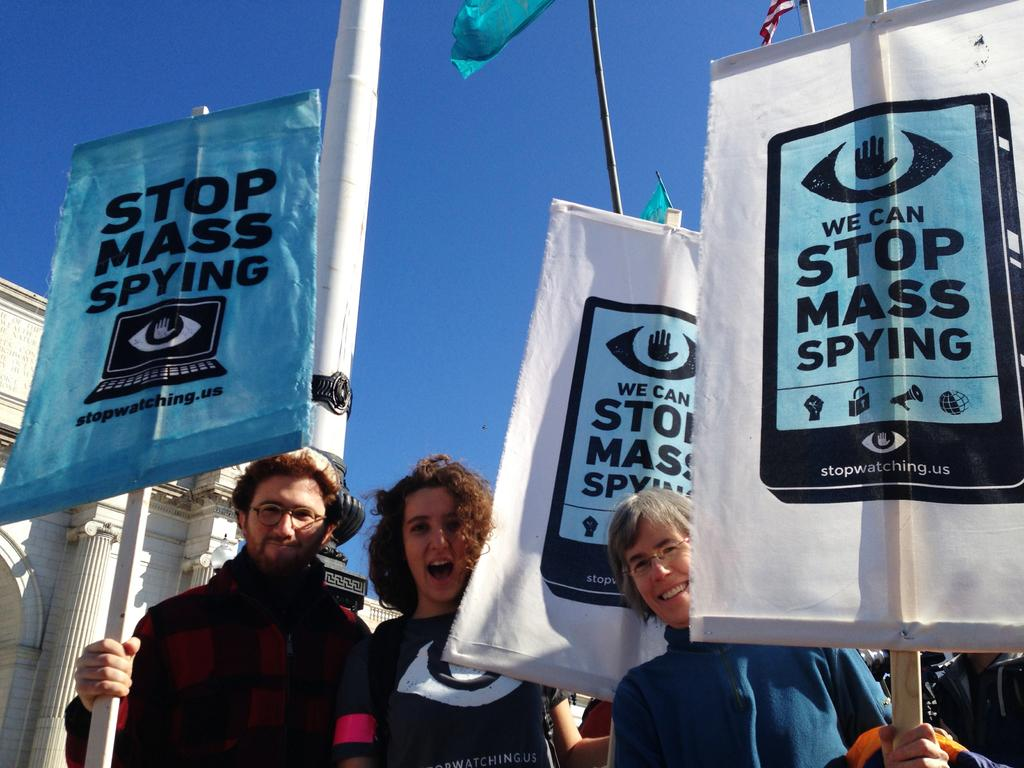What are the people in the image doing? The people are standing in the image and holding sticks with banners. What can be seen in the background of the image? There is a brick building, a pole, flags, and a blue sky in the background of the image. What type of apparel are the people wearing in the image? The provided facts do not mention the type of apparel the people are wearing in the image. --- 